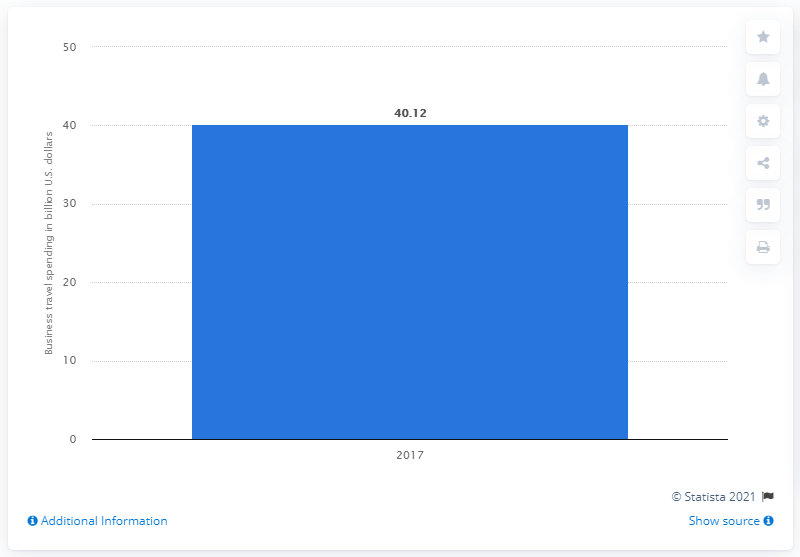Give some essential details in this illustration. In 2017, France's business travel spending was 40.12. In 2017, business travel spending in France surpassed 40.12 billion U.S. dollars. 